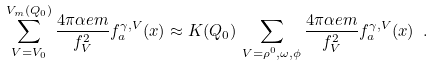<formula> <loc_0><loc_0><loc_500><loc_500>\sum _ { V = V _ { 0 } } ^ { V _ { m } ( Q _ { 0 } ) } \frac { 4 \pi \alpha e m } { f _ { V } ^ { 2 } } f _ { a } ^ { \gamma , V } ( x ) \approx K ( Q _ { 0 } ) \, \sum _ { V = \rho ^ { 0 } , \omega , \phi } \frac { 4 \pi \alpha e m } { f _ { V } ^ { 2 } } { f } _ { a } ^ { \gamma , V } ( x ) \ .</formula> 